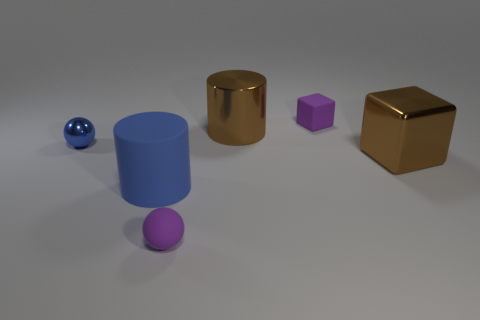What is the material of the other object that is the same shape as the large blue object?
Provide a short and direct response. Metal. There is a ball that is the same color as the matte cylinder; what is its material?
Give a very brief answer. Metal. There is a brown metallic object that is right of the cube that is behind the tiny metal thing; what shape is it?
Your response must be concise. Cube. There is a block behind the large object that is behind the tiny blue shiny thing; how many rubber blocks are to the right of it?
Provide a succinct answer. 0. Is the number of tiny purple things right of the small purple cube less than the number of big metal cubes?
Your answer should be very brief. Yes. The small purple thing that is behind the big matte cylinder has what shape?
Keep it short and to the point. Cube. What shape is the large object that is to the right of the purple matte object that is on the right side of the rubber thing in front of the rubber cylinder?
Ensure brevity in your answer.  Cube. How many things are large blocks or small purple cubes?
Your answer should be compact. 2. Do the brown object that is on the left side of the small purple block and the matte object that is to the left of the small purple matte sphere have the same shape?
Make the answer very short. Yes. How many cubes are behind the shiny cylinder and right of the purple block?
Ensure brevity in your answer.  0. 